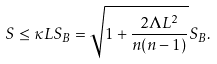Convert formula to latex. <formula><loc_0><loc_0><loc_500><loc_500>S \leq \kappa L S _ { B } = \sqrt { 1 + { \frac { 2 \Lambda L ^ { 2 } } { n ( n - 1 ) } } } S _ { B } .</formula> 